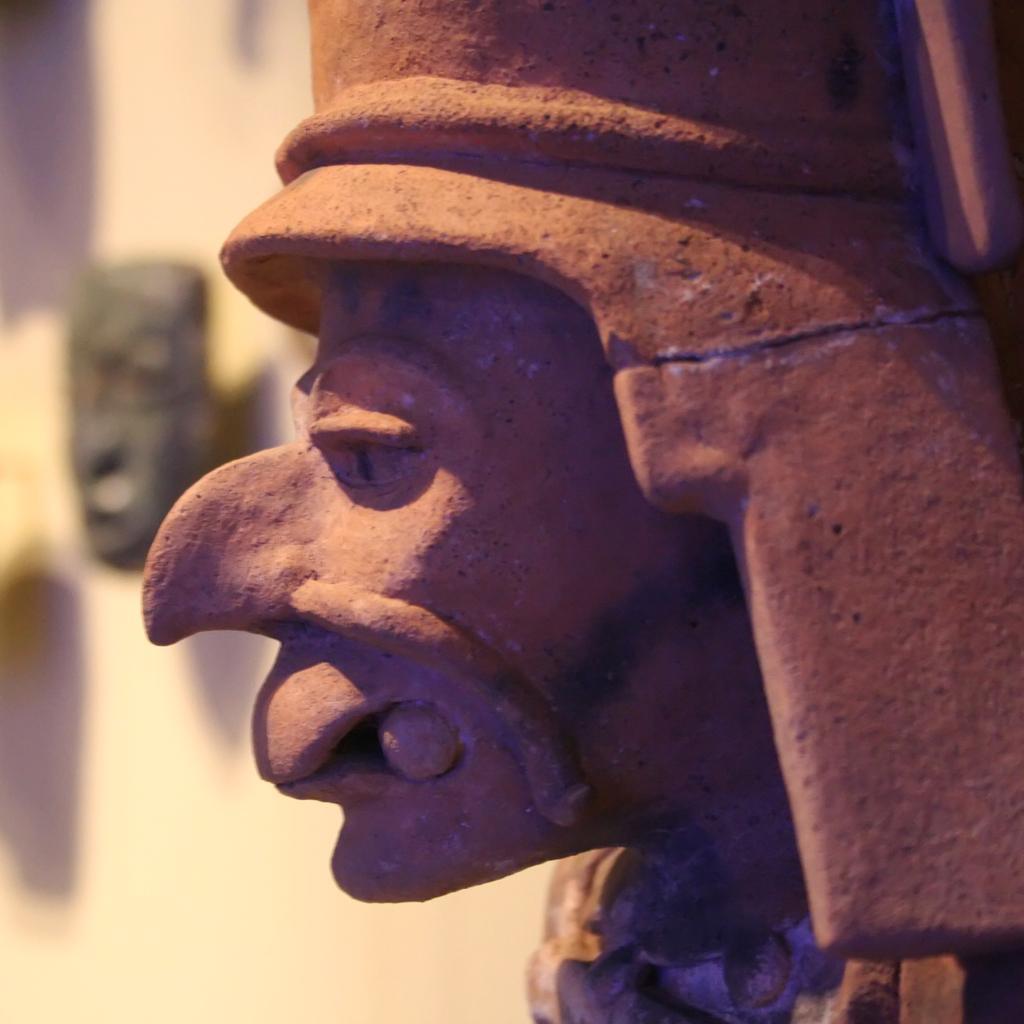How would you summarize this image in a sentence or two? In this image I can see a stone statue of a person's head which is brown in color. In the background I can see the cream colored surface and a black colored object. 